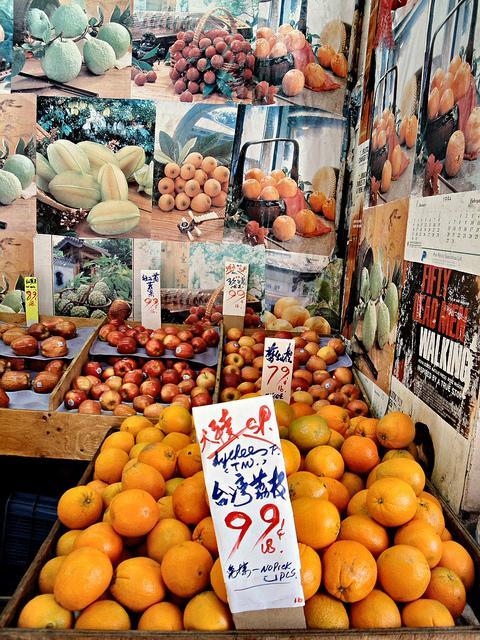How much would 2 pounds of oranges cost? 1.98 